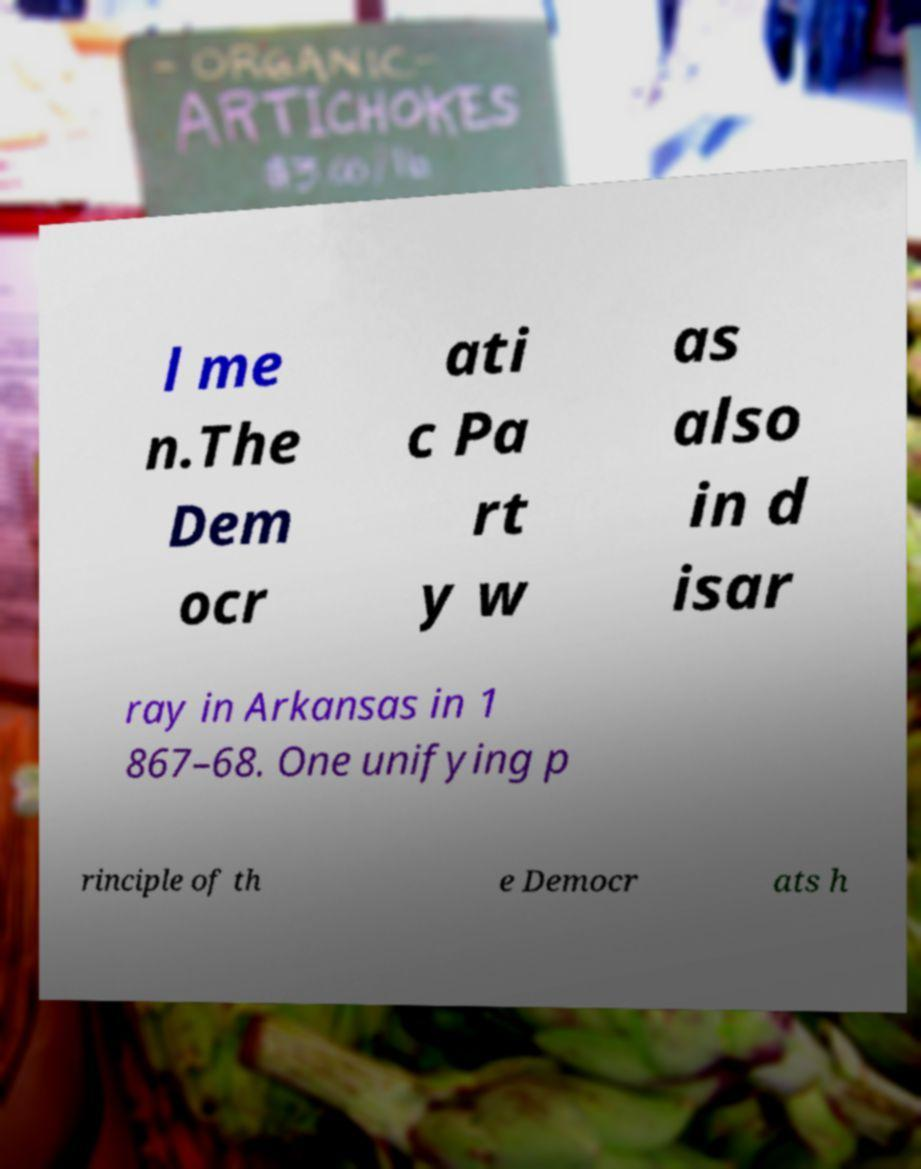For documentation purposes, I need the text within this image transcribed. Could you provide that? l me n.The Dem ocr ati c Pa rt y w as also in d isar ray in Arkansas in 1 867–68. One unifying p rinciple of th e Democr ats h 